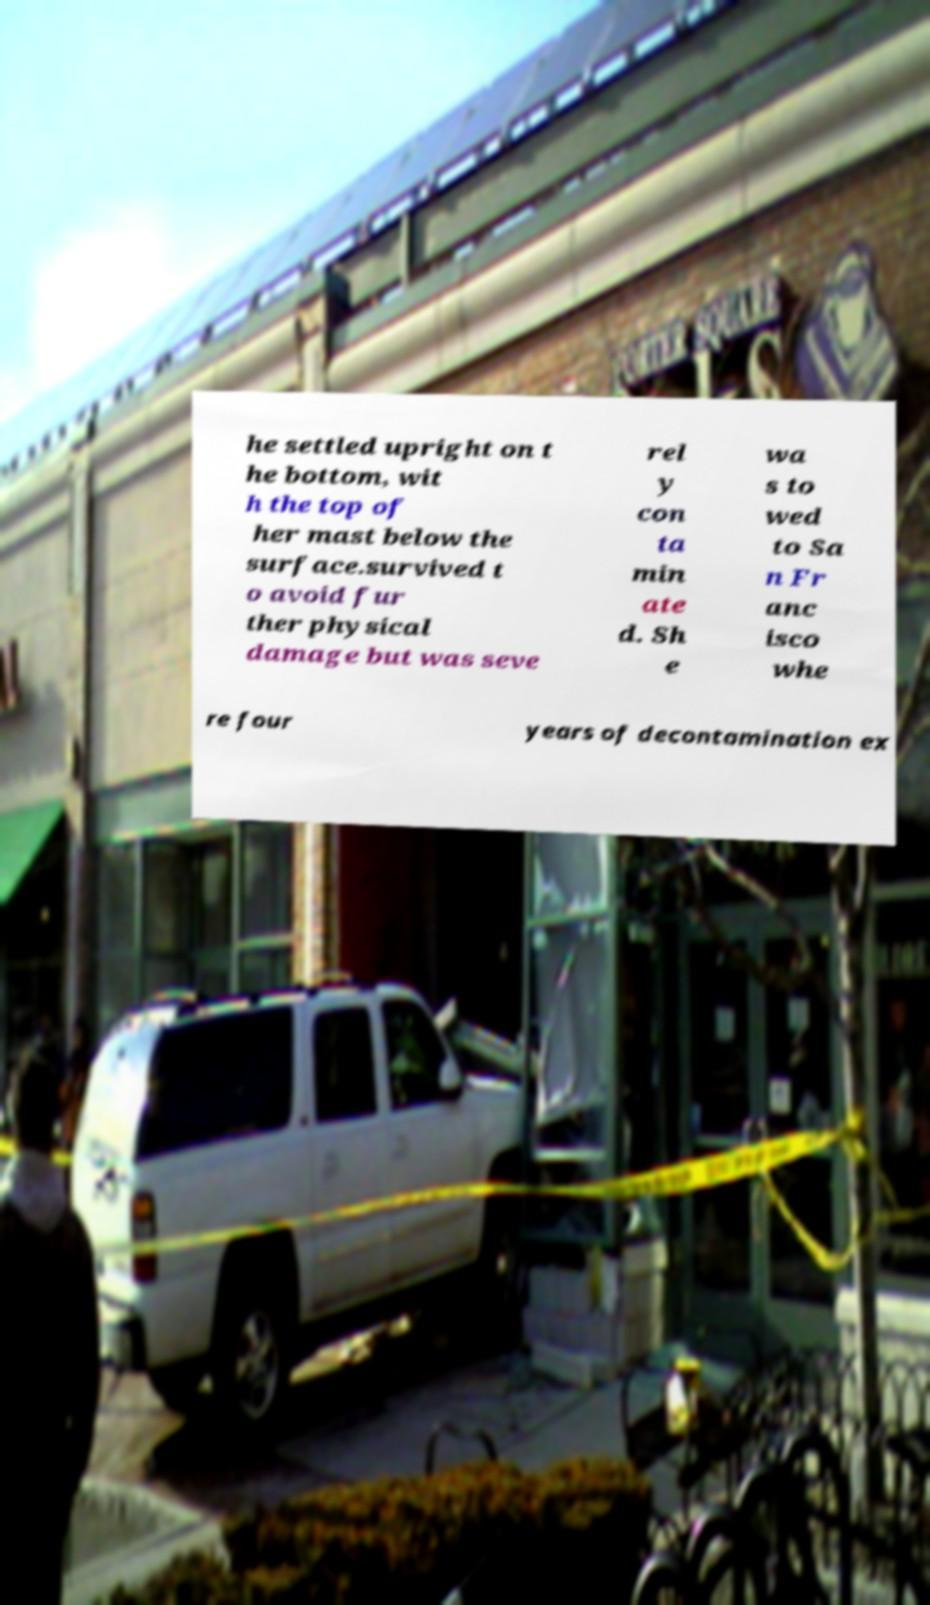What messages or text are displayed in this image? I need them in a readable, typed format. he settled upright on t he bottom, wit h the top of her mast below the surface.survived t o avoid fur ther physical damage but was seve rel y con ta min ate d. Sh e wa s to wed to Sa n Fr anc isco whe re four years of decontamination ex 